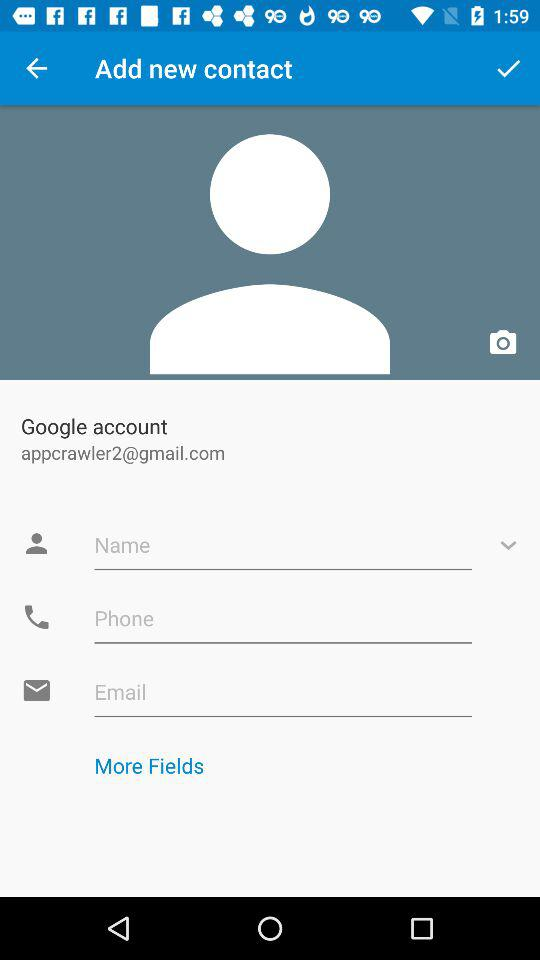How many text inputs are there for contact information?
Answer the question using a single word or phrase. 3 